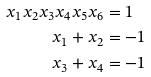Convert formula to latex. <formula><loc_0><loc_0><loc_500><loc_500>x _ { 1 } x _ { 2 } x _ { 3 } x _ { 4 } x _ { 5 } x _ { 6 } & = 1 \\ x _ { 1 } + x _ { 2 } & = - 1 \\ x _ { 3 } + x _ { 4 } & = - 1</formula> 